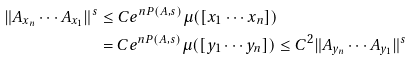Convert formula to latex. <formula><loc_0><loc_0><loc_500><loc_500>\| A _ { x _ { n } } \cdots A _ { x _ { 1 } } \| ^ { s } & \leq C e ^ { n P ( A , s ) } \mu ( [ x _ { 1 } \cdots x _ { n } ] ) \\ & = C e ^ { n P ( A , s ) } \mu ( [ y _ { 1 } \cdots y _ { n } ] ) \leq C ^ { 2 } \| A _ { y _ { n } } \cdots A _ { y _ { 1 } } \| ^ { s }</formula> 